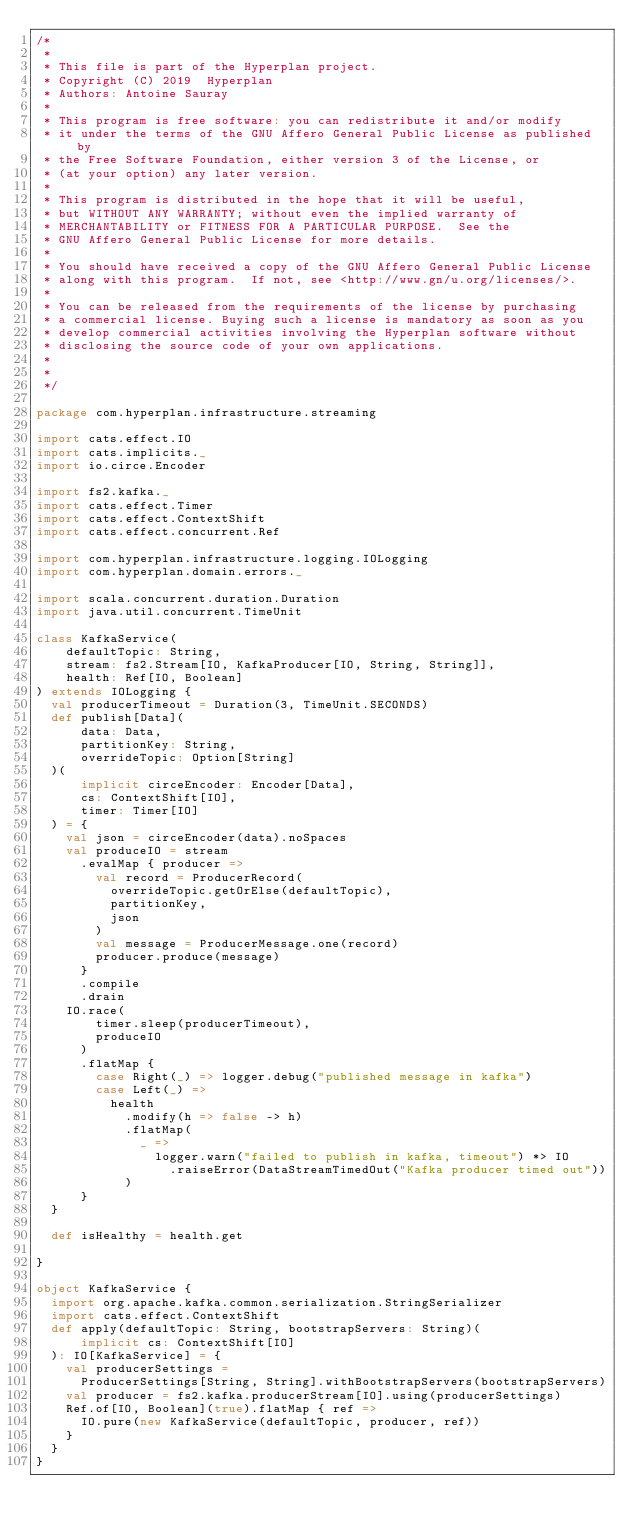<code> <loc_0><loc_0><loc_500><loc_500><_Scala_>/*
 *
 * This file is part of the Hyperplan project.
 * Copyright (C) 2019  Hyperplan
 * Authors: Antoine Sauray
 *
 * This program is free software: you can redistribute it and/or modify
 * it under the terms of the GNU Affero General Public License as published by
 * the Free Software Foundation, either version 3 of the License, or
 * (at your option) any later version.
 *
 * This program is distributed in the hope that it will be useful,
 * but WITHOUT ANY WARRANTY; without even the implied warranty of
 * MERCHANTABILITY or FITNESS FOR A PARTICULAR PURPOSE.  See the
 * GNU Affero General Public License for more details.
 *
 * You should have received a copy of the GNU Affero General Public License
 * along with this program.  If not, see <http://www.gn/u.org/licenses/>.
 *
 * You can be released from the requirements of the license by purchasing
 * a commercial license. Buying such a license is mandatory as soon as you
 * develop commercial activities involving the Hyperplan software without
 * disclosing the source code of your own applications.
 *
 *
 */

package com.hyperplan.infrastructure.streaming

import cats.effect.IO
import cats.implicits._
import io.circe.Encoder

import fs2.kafka._
import cats.effect.Timer
import cats.effect.ContextShift
import cats.effect.concurrent.Ref

import com.hyperplan.infrastructure.logging.IOLogging
import com.hyperplan.domain.errors._

import scala.concurrent.duration.Duration
import java.util.concurrent.TimeUnit

class KafkaService(
    defaultTopic: String,
    stream: fs2.Stream[IO, KafkaProducer[IO, String, String]],
    health: Ref[IO, Boolean]
) extends IOLogging {
  val producerTimeout = Duration(3, TimeUnit.SECONDS)
  def publish[Data](
      data: Data,
      partitionKey: String,
      overrideTopic: Option[String]
  )(
      implicit circeEncoder: Encoder[Data],
      cs: ContextShift[IO],
      timer: Timer[IO]
  ) = {
    val json = circeEncoder(data).noSpaces
    val produceIO = stream
      .evalMap { producer =>
        val record = ProducerRecord(
          overrideTopic.getOrElse(defaultTopic),
          partitionKey,
          json
        )
        val message = ProducerMessage.one(record)
        producer.produce(message)
      }
      .compile
      .drain
    IO.race(
        timer.sleep(producerTimeout),
        produceIO
      )
      .flatMap {
        case Right(_) => logger.debug("published message in kafka")
        case Left(_) =>
          health
            .modify(h => false -> h)
            .flatMap(
              _ =>
                logger.warn("failed to publish in kafka, timeout") *> IO
                  .raiseError(DataStreamTimedOut("Kafka producer timed out"))
            )
      }
  }

  def isHealthy = health.get

}

object KafkaService {
  import org.apache.kafka.common.serialization.StringSerializer
  import cats.effect.ContextShift
  def apply(defaultTopic: String, bootstrapServers: String)(
      implicit cs: ContextShift[IO]
  ): IO[KafkaService] = {
    val producerSettings =
      ProducerSettings[String, String].withBootstrapServers(bootstrapServers)
    val producer = fs2.kafka.producerStream[IO].using(producerSettings)
    Ref.of[IO, Boolean](true).flatMap { ref =>
      IO.pure(new KafkaService(defaultTopic, producer, ref))
    }
  }
}
</code> 